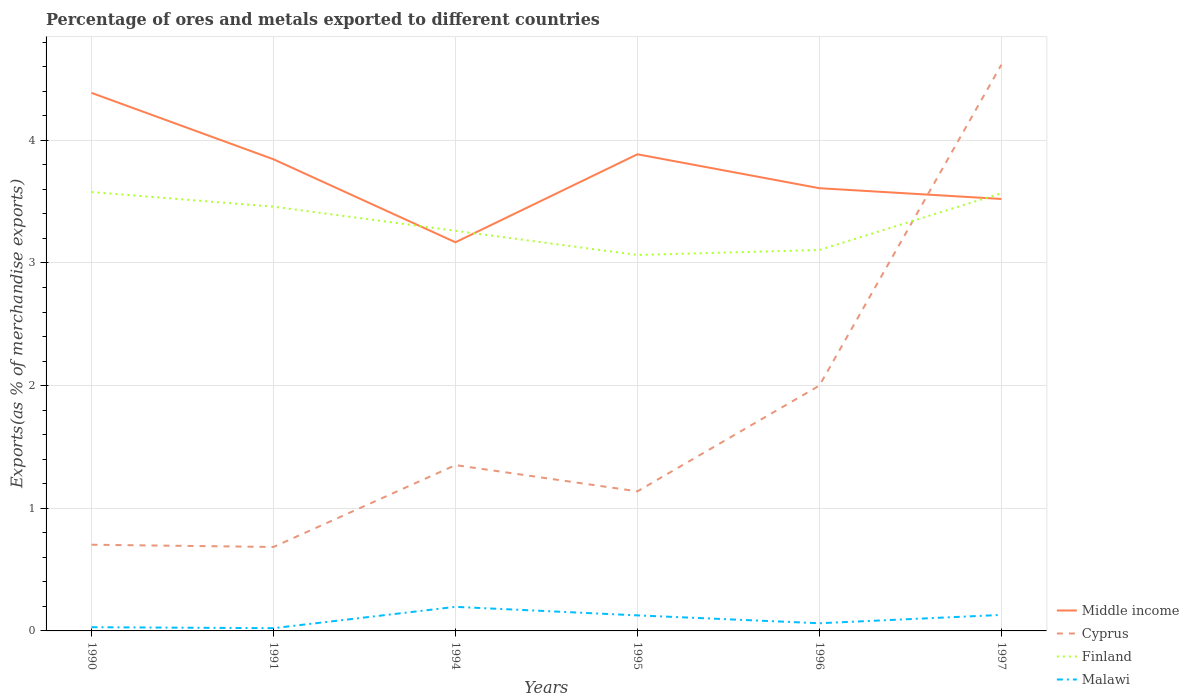Across all years, what is the maximum percentage of exports to different countries in Middle income?
Your answer should be compact. 3.17. What is the total percentage of exports to different countries in Middle income in the graph?
Keep it short and to the point. 0.78. What is the difference between the highest and the second highest percentage of exports to different countries in Malawi?
Ensure brevity in your answer.  0.17. Is the percentage of exports to different countries in Cyprus strictly greater than the percentage of exports to different countries in Malawi over the years?
Provide a short and direct response. No. How many lines are there?
Give a very brief answer. 4. Does the graph contain any zero values?
Keep it short and to the point. No. Where does the legend appear in the graph?
Your answer should be compact. Bottom right. How many legend labels are there?
Keep it short and to the point. 4. What is the title of the graph?
Provide a short and direct response. Percentage of ores and metals exported to different countries. What is the label or title of the X-axis?
Your answer should be compact. Years. What is the label or title of the Y-axis?
Ensure brevity in your answer.  Exports(as % of merchandise exports). What is the Exports(as % of merchandise exports) of Middle income in 1990?
Your response must be concise. 4.39. What is the Exports(as % of merchandise exports) in Cyprus in 1990?
Your answer should be compact. 0.7. What is the Exports(as % of merchandise exports) in Finland in 1990?
Your answer should be compact. 3.58. What is the Exports(as % of merchandise exports) in Malawi in 1990?
Ensure brevity in your answer.  0.03. What is the Exports(as % of merchandise exports) in Middle income in 1991?
Offer a very short reply. 3.85. What is the Exports(as % of merchandise exports) in Cyprus in 1991?
Keep it short and to the point. 0.68. What is the Exports(as % of merchandise exports) in Finland in 1991?
Keep it short and to the point. 3.46. What is the Exports(as % of merchandise exports) in Malawi in 1991?
Offer a very short reply. 0.02. What is the Exports(as % of merchandise exports) of Middle income in 1994?
Give a very brief answer. 3.17. What is the Exports(as % of merchandise exports) in Cyprus in 1994?
Keep it short and to the point. 1.35. What is the Exports(as % of merchandise exports) of Finland in 1994?
Your response must be concise. 3.26. What is the Exports(as % of merchandise exports) of Malawi in 1994?
Your answer should be very brief. 0.2. What is the Exports(as % of merchandise exports) of Middle income in 1995?
Your answer should be very brief. 3.89. What is the Exports(as % of merchandise exports) of Cyprus in 1995?
Provide a short and direct response. 1.14. What is the Exports(as % of merchandise exports) of Finland in 1995?
Offer a terse response. 3.07. What is the Exports(as % of merchandise exports) of Malawi in 1995?
Your answer should be compact. 0.13. What is the Exports(as % of merchandise exports) of Middle income in 1996?
Provide a succinct answer. 3.61. What is the Exports(as % of merchandise exports) in Cyprus in 1996?
Make the answer very short. 2. What is the Exports(as % of merchandise exports) in Finland in 1996?
Offer a terse response. 3.11. What is the Exports(as % of merchandise exports) of Malawi in 1996?
Provide a short and direct response. 0.06. What is the Exports(as % of merchandise exports) of Middle income in 1997?
Make the answer very short. 3.52. What is the Exports(as % of merchandise exports) in Cyprus in 1997?
Keep it short and to the point. 4.62. What is the Exports(as % of merchandise exports) of Finland in 1997?
Your response must be concise. 3.57. What is the Exports(as % of merchandise exports) of Malawi in 1997?
Provide a succinct answer. 0.13. Across all years, what is the maximum Exports(as % of merchandise exports) in Middle income?
Make the answer very short. 4.39. Across all years, what is the maximum Exports(as % of merchandise exports) of Cyprus?
Offer a very short reply. 4.62. Across all years, what is the maximum Exports(as % of merchandise exports) in Finland?
Provide a short and direct response. 3.58. Across all years, what is the maximum Exports(as % of merchandise exports) in Malawi?
Your response must be concise. 0.2. Across all years, what is the minimum Exports(as % of merchandise exports) of Middle income?
Provide a short and direct response. 3.17. Across all years, what is the minimum Exports(as % of merchandise exports) in Cyprus?
Offer a very short reply. 0.68. Across all years, what is the minimum Exports(as % of merchandise exports) in Finland?
Provide a short and direct response. 3.07. Across all years, what is the minimum Exports(as % of merchandise exports) of Malawi?
Provide a succinct answer. 0.02. What is the total Exports(as % of merchandise exports) of Middle income in the graph?
Your answer should be very brief. 22.42. What is the total Exports(as % of merchandise exports) in Cyprus in the graph?
Provide a succinct answer. 10.49. What is the total Exports(as % of merchandise exports) in Finland in the graph?
Provide a short and direct response. 20.04. What is the total Exports(as % of merchandise exports) in Malawi in the graph?
Ensure brevity in your answer.  0.57. What is the difference between the Exports(as % of merchandise exports) of Middle income in 1990 and that in 1991?
Ensure brevity in your answer.  0.54. What is the difference between the Exports(as % of merchandise exports) of Cyprus in 1990 and that in 1991?
Make the answer very short. 0.02. What is the difference between the Exports(as % of merchandise exports) of Finland in 1990 and that in 1991?
Provide a short and direct response. 0.12. What is the difference between the Exports(as % of merchandise exports) of Malawi in 1990 and that in 1991?
Offer a very short reply. 0.01. What is the difference between the Exports(as % of merchandise exports) of Middle income in 1990 and that in 1994?
Provide a short and direct response. 1.22. What is the difference between the Exports(as % of merchandise exports) of Cyprus in 1990 and that in 1994?
Offer a very short reply. -0.65. What is the difference between the Exports(as % of merchandise exports) in Finland in 1990 and that in 1994?
Provide a succinct answer. 0.32. What is the difference between the Exports(as % of merchandise exports) in Malawi in 1990 and that in 1994?
Provide a short and direct response. -0.17. What is the difference between the Exports(as % of merchandise exports) in Middle income in 1990 and that in 1995?
Give a very brief answer. 0.5. What is the difference between the Exports(as % of merchandise exports) of Cyprus in 1990 and that in 1995?
Provide a succinct answer. -0.44. What is the difference between the Exports(as % of merchandise exports) of Finland in 1990 and that in 1995?
Provide a short and direct response. 0.51. What is the difference between the Exports(as % of merchandise exports) of Malawi in 1990 and that in 1995?
Your answer should be very brief. -0.1. What is the difference between the Exports(as % of merchandise exports) of Middle income in 1990 and that in 1996?
Provide a succinct answer. 0.78. What is the difference between the Exports(as % of merchandise exports) in Cyprus in 1990 and that in 1996?
Provide a succinct answer. -1.3. What is the difference between the Exports(as % of merchandise exports) in Finland in 1990 and that in 1996?
Give a very brief answer. 0.47. What is the difference between the Exports(as % of merchandise exports) in Malawi in 1990 and that in 1996?
Provide a succinct answer. -0.03. What is the difference between the Exports(as % of merchandise exports) of Middle income in 1990 and that in 1997?
Your answer should be very brief. 0.86. What is the difference between the Exports(as % of merchandise exports) in Cyprus in 1990 and that in 1997?
Your answer should be very brief. -3.91. What is the difference between the Exports(as % of merchandise exports) of Finland in 1990 and that in 1997?
Offer a very short reply. 0.01. What is the difference between the Exports(as % of merchandise exports) in Malawi in 1990 and that in 1997?
Provide a short and direct response. -0.1. What is the difference between the Exports(as % of merchandise exports) of Middle income in 1991 and that in 1994?
Ensure brevity in your answer.  0.68. What is the difference between the Exports(as % of merchandise exports) of Cyprus in 1991 and that in 1994?
Offer a very short reply. -0.67. What is the difference between the Exports(as % of merchandise exports) of Finland in 1991 and that in 1994?
Provide a short and direct response. 0.2. What is the difference between the Exports(as % of merchandise exports) of Malawi in 1991 and that in 1994?
Offer a terse response. -0.17. What is the difference between the Exports(as % of merchandise exports) in Middle income in 1991 and that in 1995?
Keep it short and to the point. -0.04. What is the difference between the Exports(as % of merchandise exports) of Cyprus in 1991 and that in 1995?
Your answer should be compact. -0.45. What is the difference between the Exports(as % of merchandise exports) in Finland in 1991 and that in 1995?
Provide a short and direct response. 0.39. What is the difference between the Exports(as % of merchandise exports) of Malawi in 1991 and that in 1995?
Your response must be concise. -0.1. What is the difference between the Exports(as % of merchandise exports) in Middle income in 1991 and that in 1996?
Your answer should be very brief. 0.24. What is the difference between the Exports(as % of merchandise exports) of Cyprus in 1991 and that in 1996?
Your answer should be very brief. -1.32. What is the difference between the Exports(as % of merchandise exports) in Finland in 1991 and that in 1996?
Your response must be concise. 0.35. What is the difference between the Exports(as % of merchandise exports) in Malawi in 1991 and that in 1996?
Ensure brevity in your answer.  -0.04. What is the difference between the Exports(as % of merchandise exports) of Middle income in 1991 and that in 1997?
Provide a succinct answer. 0.32. What is the difference between the Exports(as % of merchandise exports) in Cyprus in 1991 and that in 1997?
Provide a succinct answer. -3.93. What is the difference between the Exports(as % of merchandise exports) of Finland in 1991 and that in 1997?
Make the answer very short. -0.11. What is the difference between the Exports(as % of merchandise exports) of Malawi in 1991 and that in 1997?
Keep it short and to the point. -0.11. What is the difference between the Exports(as % of merchandise exports) of Middle income in 1994 and that in 1995?
Make the answer very short. -0.72. What is the difference between the Exports(as % of merchandise exports) in Cyprus in 1994 and that in 1995?
Keep it short and to the point. 0.21. What is the difference between the Exports(as % of merchandise exports) of Finland in 1994 and that in 1995?
Your response must be concise. 0.2. What is the difference between the Exports(as % of merchandise exports) of Malawi in 1994 and that in 1995?
Your answer should be very brief. 0.07. What is the difference between the Exports(as % of merchandise exports) of Middle income in 1994 and that in 1996?
Keep it short and to the point. -0.44. What is the difference between the Exports(as % of merchandise exports) of Cyprus in 1994 and that in 1996?
Make the answer very short. -0.65. What is the difference between the Exports(as % of merchandise exports) of Finland in 1994 and that in 1996?
Provide a short and direct response. 0.16. What is the difference between the Exports(as % of merchandise exports) of Malawi in 1994 and that in 1996?
Give a very brief answer. 0.13. What is the difference between the Exports(as % of merchandise exports) of Middle income in 1994 and that in 1997?
Offer a terse response. -0.35. What is the difference between the Exports(as % of merchandise exports) of Cyprus in 1994 and that in 1997?
Make the answer very short. -3.26. What is the difference between the Exports(as % of merchandise exports) in Finland in 1994 and that in 1997?
Ensure brevity in your answer.  -0.31. What is the difference between the Exports(as % of merchandise exports) in Malawi in 1994 and that in 1997?
Keep it short and to the point. 0.07. What is the difference between the Exports(as % of merchandise exports) in Middle income in 1995 and that in 1996?
Offer a terse response. 0.28. What is the difference between the Exports(as % of merchandise exports) in Cyprus in 1995 and that in 1996?
Your response must be concise. -0.86. What is the difference between the Exports(as % of merchandise exports) in Finland in 1995 and that in 1996?
Make the answer very short. -0.04. What is the difference between the Exports(as % of merchandise exports) in Malawi in 1995 and that in 1996?
Make the answer very short. 0.06. What is the difference between the Exports(as % of merchandise exports) in Middle income in 1995 and that in 1997?
Provide a short and direct response. 0.36. What is the difference between the Exports(as % of merchandise exports) of Cyprus in 1995 and that in 1997?
Your response must be concise. -3.48. What is the difference between the Exports(as % of merchandise exports) in Finland in 1995 and that in 1997?
Offer a terse response. -0.5. What is the difference between the Exports(as % of merchandise exports) in Malawi in 1995 and that in 1997?
Make the answer very short. -0. What is the difference between the Exports(as % of merchandise exports) of Middle income in 1996 and that in 1997?
Your answer should be compact. 0.09. What is the difference between the Exports(as % of merchandise exports) of Cyprus in 1996 and that in 1997?
Your response must be concise. -2.62. What is the difference between the Exports(as % of merchandise exports) in Finland in 1996 and that in 1997?
Make the answer very short. -0.46. What is the difference between the Exports(as % of merchandise exports) of Malawi in 1996 and that in 1997?
Your response must be concise. -0.07. What is the difference between the Exports(as % of merchandise exports) in Middle income in 1990 and the Exports(as % of merchandise exports) in Cyprus in 1991?
Ensure brevity in your answer.  3.7. What is the difference between the Exports(as % of merchandise exports) of Middle income in 1990 and the Exports(as % of merchandise exports) of Finland in 1991?
Your response must be concise. 0.93. What is the difference between the Exports(as % of merchandise exports) in Middle income in 1990 and the Exports(as % of merchandise exports) in Malawi in 1991?
Provide a succinct answer. 4.36. What is the difference between the Exports(as % of merchandise exports) in Cyprus in 1990 and the Exports(as % of merchandise exports) in Finland in 1991?
Ensure brevity in your answer.  -2.76. What is the difference between the Exports(as % of merchandise exports) in Cyprus in 1990 and the Exports(as % of merchandise exports) in Malawi in 1991?
Make the answer very short. 0.68. What is the difference between the Exports(as % of merchandise exports) in Finland in 1990 and the Exports(as % of merchandise exports) in Malawi in 1991?
Keep it short and to the point. 3.56. What is the difference between the Exports(as % of merchandise exports) in Middle income in 1990 and the Exports(as % of merchandise exports) in Cyprus in 1994?
Give a very brief answer. 3.04. What is the difference between the Exports(as % of merchandise exports) of Middle income in 1990 and the Exports(as % of merchandise exports) of Finland in 1994?
Give a very brief answer. 1.12. What is the difference between the Exports(as % of merchandise exports) in Middle income in 1990 and the Exports(as % of merchandise exports) in Malawi in 1994?
Give a very brief answer. 4.19. What is the difference between the Exports(as % of merchandise exports) of Cyprus in 1990 and the Exports(as % of merchandise exports) of Finland in 1994?
Provide a short and direct response. -2.56. What is the difference between the Exports(as % of merchandise exports) in Cyprus in 1990 and the Exports(as % of merchandise exports) in Malawi in 1994?
Keep it short and to the point. 0.51. What is the difference between the Exports(as % of merchandise exports) of Finland in 1990 and the Exports(as % of merchandise exports) of Malawi in 1994?
Provide a succinct answer. 3.38. What is the difference between the Exports(as % of merchandise exports) of Middle income in 1990 and the Exports(as % of merchandise exports) of Cyprus in 1995?
Provide a succinct answer. 3.25. What is the difference between the Exports(as % of merchandise exports) of Middle income in 1990 and the Exports(as % of merchandise exports) of Finland in 1995?
Give a very brief answer. 1.32. What is the difference between the Exports(as % of merchandise exports) of Middle income in 1990 and the Exports(as % of merchandise exports) of Malawi in 1995?
Your answer should be compact. 4.26. What is the difference between the Exports(as % of merchandise exports) of Cyprus in 1990 and the Exports(as % of merchandise exports) of Finland in 1995?
Provide a short and direct response. -2.36. What is the difference between the Exports(as % of merchandise exports) of Cyprus in 1990 and the Exports(as % of merchandise exports) of Malawi in 1995?
Ensure brevity in your answer.  0.58. What is the difference between the Exports(as % of merchandise exports) in Finland in 1990 and the Exports(as % of merchandise exports) in Malawi in 1995?
Make the answer very short. 3.45. What is the difference between the Exports(as % of merchandise exports) of Middle income in 1990 and the Exports(as % of merchandise exports) of Cyprus in 1996?
Make the answer very short. 2.39. What is the difference between the Exports(as % of merchandise exports) in Middle income in 1990 and the Exports(as % of merchandise exports) in Finland in 1996?
Give a very brief answer. 1.28. What is the difference between the Exports(as % of merchandise exports) in Middle income in 1990 and the Exports(as % of merchandise exports) in Malawi in 1996?
Ensure brevity in your answer.  4.32. What is the difference between the Exports(as % of merchandise exports) in Cyprus in 1990 and the Exports(as % of merchandise exports) in Finland in 1996?
Provide a short and direct response. -2.4. What is the difference between the Exports(as % of merchandise exports) of Cyprus in 1990 and the Exports(as % of merchandise exports) of Malawi in 1996?
Keep it short and to the point. 0.64. What is the difference between the Exports(as % of merchandise exports) in Finland in 1990 and the Exports(as % of merchandise exports) in Malawi in 1996?
Make the answer very short. 3.52. What is the difference between the Exports(as % of merchandise exports) of Middle income in 1990 and the Exports(as % of merchandise exports) of Cyprus in 1997?
Give a very brief answer. -0.23. What is the difference between the Exports(as % of merchandise exports) of Middle income in 1990 and the Exports(as % of merchandise exports) of Finland in 1997?
Offer a terse response. 0.82. What is the difference between the Exports(as % of merchandise exports) in Middle income in 1990 and the Exports(as % of merchandise exports) in Malawi in 1997?
Provide a succinct answer. 4.26. What is the difference between the Exports(as % of merchandise exports) of Cyprus in 1990 and the Exports(as % of merchandise exports) of Finland in 1997?
Give a very brief answer. -2.87. What is the difference between the Exports(as % of merchandise exports) in Cyprus in 1990 and the Exports(as % of merchandise exports) in Malawi in 1997?
Give a very brief answer. 0.57. What is the difference between the Exports(as % of merchandise exports) of Finland in 1990 and the Exports(as % of merchandise exports) of Malawi in 1997?
Provide a succinct answer. 3.45. What is the difference between the Exports(as % of merchandise exports) of Middle income in 1991 and the Exports(as % of merchandise exports) of Cyprus in 1994?
Your response must be concise. 2.49. What is the difference between the Exports(as % of merchandise exports) in Middle income in 1991 and the Exports(as % of merchandise exports) in Finland in 1994?
Ensure brevity in your answer.  0.58. What is the difference between the Exports(as % of merchandise exports) in Middle income in 1991 and the Exports(as % of merchandise exports) in Malawi in 1994?
Offer a very short reply. 3.65. What is the difference between the Exports(as % of merchandise exports) of Cyprus in 1991 and the Exports(as % of merchandise exports) of Finland in 1994?
Provide a short and direct response. -2.58. What is the difference between the Exports(as % of merchandise exports) in Cyprus in 1991 and the Exports(as % of merchandise exports) in Malawi in 1994?
Your answer should be very brief. 0.49. What is the difference between the Exports(as % of merchandise exports) in Finland in 1991 and the Exports(as % of merchandise exports) in Malawi in 1994?
Your answer should be compact. 3.26. What is the difference between the Exports(as % of merchandise exports) in Middle income in 1991 and the Exports(as % of merchandise exports) in Cyprus in 1995?
Your response must be concise. 2.71. What is the difference between the Exports(as % of merchandise exports) in Middle income in 1991 and the Exports(as % of merchandise exports) in Finland in 1995?
Your response must be concise. 0.78. What is the difference between the Exports(as % of merchandise exports) in Middle income in 1991 and the Exports(as % of merchandise exports) in Malawi in 1995?
Ensure brevity in your answer.  3.72. What is the difference between the Exports(as % of merchandise exports) of Cyprus in 1991 and the Exports(as % of merchandise exports) of Finland in 1995?
Provide a short and direct response. -2.38. What is the difference between the Exports(as % of merchandise exports) in Cyprus in 1991 and the Exports(as % of merchandise exports) in Malawi in 1995?
Ensure brevity in your answer.  0.56. What is the difference between the Exports(as % of merchandise exports) of Finland in 1991 and the Exports(as % of merchandise exports) of Malawi in 1995?
Ensure brevity in your answer.  3.33. What is the difference between the Exports(as % of merchandise exports) in Middle income in 1991 and the Exports(as % of merchandise exports) in Cyprus in 1996?
Provide a succinct answer. 1.85. What is the difference between the Exports(as % of merchandise exports) of Middle income in 1991 and the Exports(as % of merchandise exports) of Finland in 1996?
Make the answer very short. 0.74. What is the difference between the Exports(as % of merchandise exports) in Middle income in 1991 and the Exports(as % of merchandise exports) in Malawi in 1996?
Ensure brevity in your answer.  3.78. What is the difference between the Exports(as % of merchandise exports) of Cyprus in 1991 and the Exports(as % of merchandise exports) of Finland in 1996?
Provide a succinct answer. -2.42. What is the difference between the Exports(as % of merchandise exports) of Cyprus in 1991 and the Exports(as % of merchandise exports) of Malawi in 1996?
Offer a terse response. 0.62. What is the difference between the Exports(as % of merchandise exports) of Finland in 1991 and the Exports(as % of merchandise exports) of Malawi in 1996?
Give a very brief answer. 3.4. What is the difference between the Exports(as % of merchandise exports) in Middle income in 1991 and the Exports(as % of merchandise exports) in Cyprus in 1997?
Your answer should be compact. -0.77. What is the difference between the Exports(as % of merchandise exports) in Middle income in 1991 and the Exports(as % of merchandise exports) in Finland in 1997?
Offer a terse response. 0.28. What is the difference between the Exports(as % of merchandise exports) of Middle income in 1991 and the Exports(as % of merchandise exports) of Malawi in 1997?
Provide a short and direct response. 3.72. What is the difference between the Exports(as % of merchandise exports) of Cyprus in 1991 and the Exports(as % of merchandise exports) of Finland in 1997?
Give a very brief answer. -2.88. What is the difference between the Exports(as % of merchandise exports) in Cyprus in 1991 and the Exports(as % of merchandise exports) in Malawi in 1997?
Provide a short and direct response. 0.55. What is the difference between the Exports(as % of merchandise exports) in Finland in 1991 and the Exports(as % of merchandise exports) in Malawi in 1997?
Offer a very short reply. 3.33. What is the difference between the Exports(as % of merchandise exports) of Middle income in 1994 and the Exports(as % of merchandise exports) of Cyprus in 1995?
Offer a very short reply. 2.03. What is the difference between the Exports(as % of merchandise exports) in Middle income in 1994 and the Exports(as % of merchandise exports) in Finland in 1995?
Provide a short and direct response. 0.1. What is the difference between the Exports(as % of merchandise exports) of Middle income in 1994 and the Exports(as % of merchandise exports) of Malawi in 1995?
Give a very brief answer. 3.04. What is the difference between the Exports(as % of merchandise exports) of Cyprus in 1994 and the Exports(as % of merchandise exports) of Finland in 1995?
Your answer should be compact. -1.71. What is the difference between the Exports(as % of merchandise exports) of Cyprus in 1994 and the Exports(as % of merchandise exports) of Malawi in 1995?
Your answer should be compact. 1.23. What is the difference between the Exports(as % of merchandise exports) of Finland in 1994 and the Exports(as % of merchandise exports) of Malawi in 1995?
Offer a terse response. 3.14. What is the difference between the Exports(as % of merchandise exports) in Middle income in 1994 and the Exports(as % of merchandise exports) in Cyprus in 1996?
Offer a very short reply. 1.17. What is the difference between the Exports(as % of merchandise exports) of Middle income in 1994 and the Exports(as % of merchandise exports) of Finland in 1996?
Keep it short and to the point. 0.06. What is the difference between the Exports(as % of merchandise exports) in Middle income in 1994 and the Exports(as % of merchandise exports) in Malawi in 1996?
Your answer should be very brief. 3.11. What is the difference between the Exports(as % of merchandise exports) in Cyprus in 1994 and the Exports(as % of merchandise exports) in Finland in 1996?
Your response must be concise. -1.75. What is the difference between the Exports(as % of merchandise exports) of Cyprus in 1994 and the Exports(as % of merchandise exports) of Malawi in 1996?
Ensure brevity in your answer.  1.29. What is the difference between the Exports(as % of merchandise exports) in Finland in 1994 and the Exports(as % of merchandise exports) in Malawi in 1996?
Your answer should be compact. 3.2. What is the difference between the Exports(as % of merchandise exports) of Middle income in 1994 and the Exports(as % of merchandise exports) of Cyprus in 1997?
Provide a succinct answer. -1.45. What is the difference between the Exports(as % of merchandise exports) of Middle income in 1994 and the Exports(as % of merchandise exports) of Finland in 1997?
Your response must be concise. -0.4. What is the difference between the Exports(as % of merchandise exports) of Middle income in 1994 and the Exports(as % of merchandise exports) of Malawi in 1997?
Keep it short and to the point. 3.04. What is the difference between the Exports(as % of merchandise exports) of Cyprus in 1994 and the Exports(as % of merchandise exports) of Finland in 1997?
Ensure brevity in your answer.  -2.22. What is the difference between the Exports(as % of merchandise exports) of Cyprus in 1994 and the Exports(as % of merchandise exports) of Malawi in 1997?
Offer a very short reply. 1.22. What is the difference between the Exports(as % of merchandise exports) in Finland in 1994 and the Exports(as % of merchandise exports) in Malawi in 1997?
Give a very brief answer. 3.13. What is the difference between the Exports(as % of merchandise exports) in Middle income in 1995 and the Exports(as % of merchandise exports) in Cyprus in 1996?
Give a very brief answer. 1.89. What is the difference between the Exports(as % of merchandise exports) of Middle income in 1995 and the Exports(as % of merchandise exports) of Finland in 1996?
Keep it short and to the point. 0.78. What is the difference between the Exports(as % of merchandise exports) in Middle income in 1995 and the Exports(as % of merchandise exports) in Malawi in 1996?
Provide a short and direct response. 3.82. What is the difference between the Exports(as % of merchandise exports) in Cyprus in 1995 and the Exports(as % of merchandise exports) in Finland in 1996?
Ensure brevity in your answer.  -1.97. What is the difference between the Exports(as % of merchandise exports) in Cyprus in 1995 and the Exports(as % of merchandise exports) in Malawi in 1996?
Give a very brief answer. 1.08. What is the difference between the Exports(as % of merchandise exports) in Finland in 1995 and the Exports(as % of merchandise exports) in Malawi in 1996?
Offer a terse response. 3. What is the difference between the Exports(as % of merchandise exports) of Middle income in 1995 and the Exports(as % of merchandise exports) of Cyprus in 1997?
Keep it short and to the point. -0.73. What is the difference between the Exports(as % of merchandise exports) of Middle income in 1995 and the Exports(as % of merchandise exports) of Finland in 1997?
Offer a very short reply. 0.32. What is the difference between the Exports(as % of merchandise exports) of Middle income in 1995 and the Exports(as % of merchandise exports) of Malawi in 1997?
Your answer should be very brief. 3.76. What is the difference between the Exports(as % of merchandise exports) of Cyprus in 1995 and the Exports(as % of merchandise exports) of Finland in 1997?
Your answer should be compact. -2.43. What is the difference between the Exports(as % of merchandise exports) in Cyprus in 1995 and the Exports(as % of merchandise exports) in Malawi in 1997?
Your answer should be very brief. 1.01. What is the difference between the Exports(as % of merchandise exports) of Finland in 1995 and the Exports(as % of merchandise exports) of Malawi in 1997?
Ensure brevity in your answer.  2.93. What is the difference between the Exports(as % of merchandise exports) of Middle income in 1996 and the Exports(as % of merchandise exports) of Cyprus in 1997?
Your response must be concise. -1.01. What is the difference between the Exports(as % of merchandise exports) in Middle income in 1996 and the Exports(as % of merchandise exports) in Finland in 1997?
Make the answer very short. 0.04. What is the difference between the Exports(as % of merchandise exports) in Middle income in 1996 and the Exports(as % of merchandise exports) in Malawi in 1997?
Provide a short and direct response. 3.48. What is the difference between the Exports(as % of merchandise exports) of Cyprus in 1996 and the Exports(as % of merchandise exports) of Finland in 1997?
Keep it short and to the point. -1.57. What is the difference between the Exports(as % of merchandise exports) of Cyprus in 1996 and the Exports(as % of merchandise exports) of Malawi in 1997?
Give a very brief answer. 1.87. What is the difference between the Exports(as % of merchandise exports) of Finland in 1996 and the Exports(as % of merchandise exports) of Malawi in 1997?
Offer a very short reply. 2.98. What is the average Exports(as % of merchandise exports) of Middle income per year?
Ensure brevity in your answer.  3.74. What is the average Exports(as % of merchandise exports) in Cyprus per year?
Make the answer very short. 1.75. What is the average Exports(as % of merchandise exports) in Finland per year?
Your answer should be compact. 3.34. What is the average Exports(as % of merchandise exports) of Malawi per year?
Give a very brief answer. 0.09. In the year 1990, what is the difference between the Exports(as % of merchandise exports) of Middle income and Exports(as % of merchandise exports) of Cyprus?
Make the answer very short. 3.68. In the year 1990, what is the difference between the Exports(as % of merchandise exports) in Middle income and Exports(as % of merchandise exports) in Finland?
Give a very brief answer. 0.81. In the year 1990, what is the difference between the Exports(as % of merchandise exports) of Middle income and Exports(as % of merchandise exports) of Malawi?
Your answer should be compact. 4.36. In the year 1990, what is the difference between the Exports(as % of merchandise exports) in Cyprus and Exports(as % of merchandise exports) in Finland?
Provide a succinct answer. -2.88. In the year 1990, what is the difference between the Exports(as % of merchandise exports) in Cyprus and Exports(as % of merchandise exports) in Malawi?
Give a very brief answer. 0.67. In the year 1990, what is the difference between the Exports(as % of merchandise exports) in Finland and Exports(as % of merchandise exports) in Malawi?
Provide a short and direct response. 3.55. In the year 1991, what is the difference between the Exports(as % of merchandise exports) of Middle income and Exports(as % of merchandise exports) of Cyprus?
Provide a short and direct response. 3.16. In the year 1991, what is the difference between the Exports(as % of merchandise exports) of Middle income and Exports(as % of merchandise exports) of Finland?
Give a very brief answer. 0.39. In the year 1991, what is the difference between the Exports(as % of merchandise exports) in Middle income and Exports(as % of merchandise exports) in Malawi?
Your answer should be very brief. 3.82. In the year 1991, what is the difference between the Exports(as % of merchandise exports) in Cyprus and Exports(as % of merchandise exports) in Finland?
Offer a terse response. -2.77. In the year 1991, what is the difference between the Exports(as % of merchandise exports) in Cyprus and Exports(as % of merchandise exports) in Malawi?
Offer a very short reply. 0.66. In the year 1991, what is the difference between the Exports(as % of merchandise exports) in Finland and Exports(as % of merchandise exports) in Malawi?
Provide a short and direct response. 3.44. In the year 1994, what is the difference between the Exports(as % of merchandise exports) of Middle income and Exports(as % of merchandise exports) of Cyprus?
Make the answer very short. 1.82. In the year 1994, what is the difference between the Exports(as % of merchandise exports) of Middle income and Exports(as % of merchandise exports) of Finland?
Offer a terse response. -0.09. In the year 1994, what is the difference between the Exports(as % of merchandise exports) in Middle income and Exports(as % of merchandise exports) in Malawi?
Offer a terse response. 2.97. In the year 1994, what is the difference between the Exports(as % of merchandise exports) of Cyprus and Exports(as % of merchandise exports) of Finland?
Offer a very short reply. -1.91. In the year 1994, what is the difference between the Exports(as % of merchandise exports) of Cyprus and Exports(as % of merchandise exports) of Malawi?
Keep it short and to the point. 1.16. In the year 1994, what is the difference between the Exports(as % of merchandise exports) in Finland and Exports(as % of merchandise exports) in Malawi?
Ensure brevity in your answer.  3.07. In the year 1995, what is the difference between the Exports(as % of merchandise exports) of Middle income and Exports(as % of merchandise exports) of Cyprus?
Provide a short and direct response. 2.75. In the year 1995, what is the difference between the Exports(as % of merchandise exports) of Middle income and Exports(as % of merchandise exports) of Finland?
Your answer should be very brief. 0.82. In the year 1995, what is the difference between the Exports(as % of merchandise exports) of Middle income and Exports(as % of merchandise exports) of Malawi?
Provide a short and direct response. 3.76. In the year 1995, what is the difference between the Exports(as % of merchandise exports) in Cyprus and Exports(as % of merchandise exports) in Finland?
Offer a very short reply. -1.93. In the year 1995, what is the difference between the Exports(as % of merchandise exports) in Cyprus and Exports(as % of merchandise exports) in Malawi?
Provide a succinct answer. 1.01. In the year 1995, what is the difference between the Exports(as % of merchandise exports) in Finland and Exports(as % of merchandise exports) in Malawi?
Keep it short and to the point. 2.94. In the year 1996, what is the difference between the Exports(as % of merchandise exports) of Middle income and Exports(as % of merchandise exports) of Cyprus?
Your response must be concise. 1.61. In the year 1996, what is the difference between the Exports(as % of merchandise exports) of Middle income and Exports(as % of merchandise exports) of Finland?
Your answer should be compact. 0.5. In the year 1996, what is the difference between the Exports(as % of merchandise exports) of Middle income and Exports(as % of merchandise exports) of Malawi?
Provide a short and direct response. 3.55. In the year 1996, what is the difference between the Exports(as % of merchandise exports) in Cyprus and Exports(as % of merchandise exports) in Finland?
Provide a succinct answer. -1.11. In the year 1996, what is the difference between the Exports(as % of merchandise exports) of Cyprus and Exports(as % of merchandise exports) of Malawi?
Give a very brief answer. 1.94. In the year 1996, what is the difference between the Exports(as % of merchandise exports) of Finland and Exports(as % of merchandise exports) of Malawi?
Keep it short and to the point. 3.04. In the year 1997, what is the difference between the Exports(as % of merchandise exports) of Middle income and Exports(as % of merchandise exports) of Cyprus?
Give a very brief answer. -1.09. In the year 1997, what is the difference between the Exports(as % of merchandise exports) in Middle income and Exports(as % of merchandise exports) in Finland?
Provide a succinct answer. -0.05. In the year 1997, what is the difference between the Exports(as % of merchandise exports) in Middle income and Exports(as % of merchandise exports) in Malawi?
Offer a very short reply. 3.39. In the year 1997, what is the difference between the Exports(as % of merchandise exports) of Cyprus and Exports(as % of merchandise exports) of Finland?
Your response must be concise. 1.05. In the year 1997, what is the difference between the Exports(as % of merchandise exports) in Cyprus and Exports(as % of merchandise exports) in Malawi?
Make the answer very short. 4.49. In the year 1997, what is the difference between the Exports(as % of merchandise exports) of Finland and Exports(as % of merchandise exports) of Malawi?
Offer a very short reply. 3.44. What is the ratio of the Exports(as % of merchandise exports) of Middle income in 1990 to that in 1991?
Give a very brief answer. 1.14. What is the ratio of the Exports(as % of merchandise exports) in Cyprus in 1990 to that in 1991?
Your answer should be compact. 1.03. What is the ratio of the Exports(as % of merchandise exports) of Finland in 1990 to that in 1991?
Offer a very short reply. 1.03. What is the ratio of the Exports(as % of merchandise exports) in Malawi in 1990 to that in 1991?
Keep it short and to the point. 1.36. What is the ratio of the Exports(as % of merchandise exports) in Middle income in 1990 to that in 1994?
Provide a short and direct response. 1.38. What is the ratio of the Exports(as % of merchandise exports) in Cyprus in 1990 to that in 1994?
Ensure brevity in your answer.  0.52. What is the ratio of the Exports(as % of merchandise exports) in Finland in 1990 to that in 1994?
Offer a very short reply. 1.1. What is the ratio of the Exports(as % of merchandise exports) of Malawi in 1990 to that in 1994?
Offer a very short reply. 0.15. What is the ratio of the Exports(as % of merchandise exports) in Middle income in 1990 to that in 1995?
Your answer should be compact. 1.13. What is the ratio of the Exports(as % of merchandise exports) in Cyprus in 1990 to that in 1995?
Make the answer very short. 0.62. What is the ratio of the Exports(as % of merchandise exports) in Finland in 1990 to that in 1995?
Your response must be concise. 1.17. What is the ratio of the Exports(as % of merchandise exports) in Malawi in 1990 to that in 1995?
Give a very brief answer. 0.24. What is the ratio of the Exports(as % of merchandise exports) of Middle income in 1990 to that in 1996?
Offer a terse response. 1.22. What is the ratio of the Exports(as % of merchandise exports) in Cyprus in 1990 to that in 1996?
Offer a terse response. 0.35. What is the ratio of the Exports(as % of merchandise exports) in Finland in 1990 to that in 1996?
Provide a short and direct response. 1.15. What is the ratio of the Exports(as % of merchandise exports) in Malawi in 1990 to that in 1996?
Offer a terse response. 0.48. What is the ratio of the Exports(as % of merchandise exports) of Middle income in 1990 to that in 1997?
Keep it short and to the point. 1.25. What is the ratio of the Exports(as % of merchandise exports) of Cyprus in 1990 to that in 1997?
Your response must be concise. 0.15. What is the ratio of the Exports(as % of merchandise exports) of Finland in 1990 to that in 1997?
Ensure brevity in your answer.  1. What is the ratio of the Exports(as % of merchandise exports) in Malawi in 1990 to that in 1997?
Your answer should be compact. 0.23. What is the ratio of the Exports(as % of merchandise exports) in Middle income in 1991 to that in 1994?
Ensure brevity in your answer.  1.21. What is the ratio of the Exports(as % of merchandise exports) in Cyprus in 1991 to that in 1994?
Give a very brief answer. 0.51. What is the ratio of the Exports(as % of merchandise exports) in Finland in 1991 to that in 1994?
Ensure brevity in your answer.  1.06. What is the ratio of the Exports(as % of merchandise exports) of Malawi in 1991 to that in 1994?
Make the answer very short. 0.11. What is the ratio of the Exports(as % of merchandise exports) of Cyprus in 1991 to that in 1995?
Your answer should be compact. 0.6. What is the ratio of the Exports(as % of merchandise exports) in Finland in 1991 to that in 1995?
Provide a short and direct response. 1.13. What is the ratio of the Exports(as % of merchandise exports) in Malawi in 1991 to that in 1995?
Make the answer very short. 0.18. What is the ratio of the Exports(as % of merchandise exports) in Middle income in 1991 to that in 1996?
Give a very brief answer. 1.07. What is the ratio of the Exports(as % of merchandise exports) in Cyprus in 1991 to that in 1996?
Keep it short and to the point. 0.34. What is the ratio of the Exports(as % of merchandise exports) in Finland in 1991 to that in 1996?
Provide a succinct answer. 1.11. What is the ratio of the Exports(as % of merchandise exports) in Malawi in 1991 to that in 1996?
Offer a very short reply. 0.36. What is the ratio of the Exports(as % of merchandise exports) of Middle income in 1991 to that in 1997?
Your response must be concise. 1.09. What is the ratio of the Exports(as % of merchandise exports) in Cyprus in 1991 to that in 1997?
Offer a very short reply. 0.15. What is the ratio of the Exports(as % of merchandise exports) of Finland in 1991 to that in 1997?
Your answer should be compact. 0.97. What is the ratio of the Exports(as % of merchandise exports) of Malawi in 1991 to that in 1997?
Provide a succinct answer. 0.17. What is the ratio of the Exports(as % of merchandise exports) of Middle income in 1994 to that in 1995?
Provide a short and direct response. 0.82. What is the ratio of the Exports(as % of merchandise exports) in Cyprus in 1994 to that in 1995?
Keep it short and to the point. 1.19. What is the ratio of the Exports(as % of merchandise exports) in Finland in 1994 to that in 1995?
Give a very brief answer. 1.06. What is the ratio of the Exports(as % of merchandise exports) of Malawi in 1994 to that in 1995?
Give a very brief answer. 1.55. What is the ratio of the Exports(as % of merchandise exports) in Middle income in 1994 to that in 1996?
Provide a succinct answer. 0.88. What is the ratio of the Exports(as % of merchandise exports) of Cyprus in 1994 to that in 1996?
Offer a very short reply. 0.68. What is the ratio of the Exports(as % of merchandise exports) of Finland in 1994 to that in 1996?
Make the answer very short. 1.05. What is the ratio of the Exports(as % of merchandise exports) in Malawi in 1994 to that in 1996?
Your response must be concise. 3.14. What is the ratio of the Exports(as % of merchandise exports) of Middle income in 1994 to that in 1997?
Keep it short and to the point. 0.9. What is the ratio of the Exports(as % of merchandise exports) of Cyprus in 1994 to that in 1997?
Provide a succinct answer. 0.29. What is the ratio of the Exports(as % of merchandise exports) in Finland in 1994 to that in 1997?
Provide a short and direct response. 0.91. What is the ratio of the Exports(as % of merchandise exports) in Malawi in 1994 to that in 1997?
Provide a short and direct response. 1.5. What is the ratio of the Exports(as % of merchandise exports) in Middle income in 1995 to that in 1996?
Make the answer very short. 1.08. What is the ratio of the Exports(as % of merchandise exports) in Cyprus in 1995 to that in 1996?
Provide a short and direct response. 0.57. What is the ratio of the Exports(as % of merchandise exports) in Finland in 1995 to that in 1996?
Ensure brevity in your answer.  0.99. What is the ratio of the Exports(as % of merchandise exports) of Malawi in 1995 to that in 1996?
Offer a very short reply. 2.02. What is the ratio of the Exports(as % of merchandise exports) in Middle income in 1995 to that in 1997?
Keep it short and to the point. 1.1. What is the ratio of the Exports(as % of merchandise exports) in Cyprus in 1995 to that in 1997?
Offer a terse response. 0.25. What is the ratio of the Exports(as % of merchandise exports) in Finland in 1995 to that in 1997?
Your response must be concise. 0.86. What is the ratio of the Exports(as % of merchandise exports) of Malawi in 1995 to that in 1997?
Make the answer very short. 0.97. What is the ratio of the Exports(as % of merchandise exports) of Middle income in 1996 to that in 1997?
Offer a terse response. 1.02. What is the ratio of the Exports(as % of merchandise exports) of Cyprus in 1996 to that in 1997?
Make the answer very short. 0.43. What is the ratio of the Exports(as % of merchandise exports) in Finland in 1996 to that in 1997?
Ensure brevity in your answer.  0.87. What is the ratio of the Exports(as % of merchandise exports) of Malawi in 1996 to that in 1997?
Give a very brief answer. 0.48. What is the difference between the highest and the second highest Exports(as % of merchandise exports) of Middle income?
Your answer should be very brief. 0.5. What is the difference between the highest and the second highest Exports(as % of merchandise exports) in Cyprus?
Your answer should be very brief. 2.62. What is the difference between the highest and the second highest Exports(as % of merchandise exports) in Finland?
Provide a succinct answer. 0.01. What is the difference between the highest and the second highest Exports(as % of merchandise exports) of Malawi?
Keep it short and to the point. 0.07. What is the difference between the highest and the lowest Exports(as % of merchandise exports) of Middle income?
Offer a terse response. 1.22. What is the difference between the highest and the lowest Exports(as % of merchandise exports) of Cyprus?
Make the answer very short. 3.93. What is the difference between the highest and the lowest Exports(as % of merchandise exports) of Finland?
Make the answer very short. 0.51. What is the difference between the highest and the lowest Exports(as % of merchandise exports) in Malawi?
Offer a terse response. 0.17. 